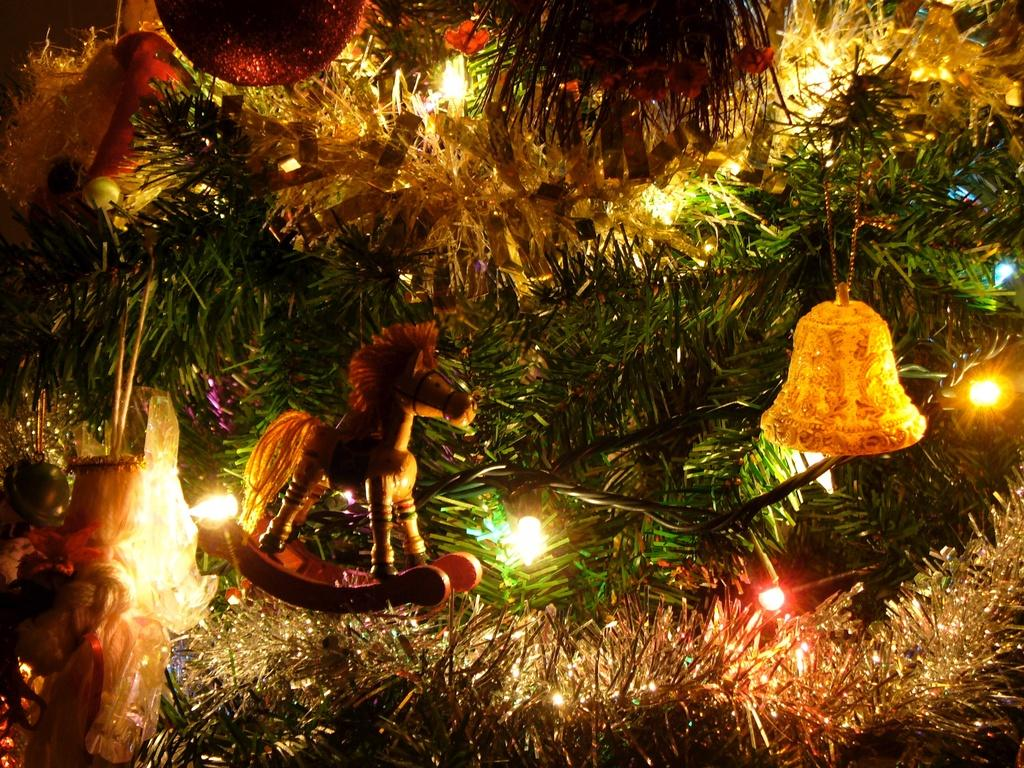What objects can be seen in the image? There are lights, a horse toy, and a bell in yellow color in the image. Can you describe the horse toy in the image? The horse toy is a toy that resembles a horse. What color is the bell in the image? The bell in the image is yellow. What type of loss is depicted in the image? There is no depiction of loss in the image; it features lights, a horse toy, and a bell. What season is suggested by the image? The image does not suggest a specific season, as there are no seasonal elements present. 